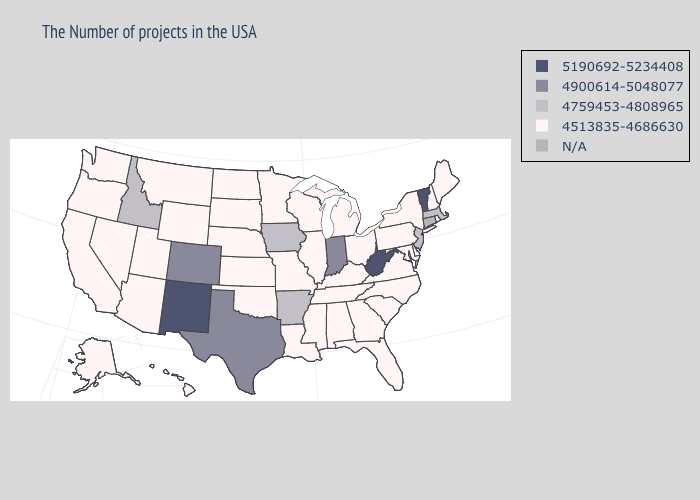What is the value of Oregon?
Answer briefly. 4513835-4686630. Name the states that have a value in the range 5190692-5234408?
Write a very short answer. Vermont, West Virginia, New Mexico. Name the states that have a value in the range 5190692-5234408?
Give a very brief answer. Vermont, West Virginia, New Mexico. What is the value of Nebraska?
Write a very short answer. 4513835-4686630. Does New Mexico have the lowest value in the West?
Keep it brief. No. Is the legend a continuous bar?
Be succinct. No. Name the states that have a value in the range 4900614-5048077?
Concise answer only. Indiana, Texas, Colorado. Name the states that have a value in the range N/A?
Write a very short answer. Connecticut. Name the states that have a value in the range 4513835-4686630?
Be succinct. Maine, Rhode Island, New Hampshire, New York, Delaware, Maryland, Pennsylvania, Virginia, North Carolina, South Carolina, Ohio, Florida, Georgia, Michigan, Kentucky, Alabama, Tennessee, Wisconsin, Illinois, Mississippi, Louisiana, Missouri, Minnesota, Kansas, Nebraska, Oklahoma, South Dakota, North Dakota, Wyoming, Utah, Montana, Arizona, Nevada, California, Washington, Oregon, Alaska, Hawaii. Which states have the lowest value in the USA?
Concise answer only. Maine, Rhode Island, New Hampshire, New York, Delaware, Maryland, Pennsylvania, Virginia, North Carolina, South Carolina, Ohio, Florida, Georgia, Michigan, Kentucky, Alabama, Tennessee, Wisconsin, Illinois, Mississippi, Louisiana, Missouri, Minnesota, Kansas, Nebraska, Oklahoma, South Dakota, North Dakota, Wyoming, Utah, Montana, Arizona, Nevada, California, Washington, Oregon, Alaska, Hawaii. Name the states that have a value in the range 4513835-4686630?
Quick response, please. Maine, Rhode Island, New Hampshire, New York, Delaware, Maryland, Pennsylvania, Virginia, North Carolina, South Carolina, Ohio, Florida, Georgia, Michigan, Kentucky, Alabama, Tennessee, Wisconsin, Illinois, Mississippi, Louisiana, Missouri, Minnesota, Kansas, Nebraska, Oklahoma, South Dakota, North Dakota, Wyoming, Utah, Montana, Arizona, Nevada, California, Washington, Oregon, Alaska, Hawaii. 